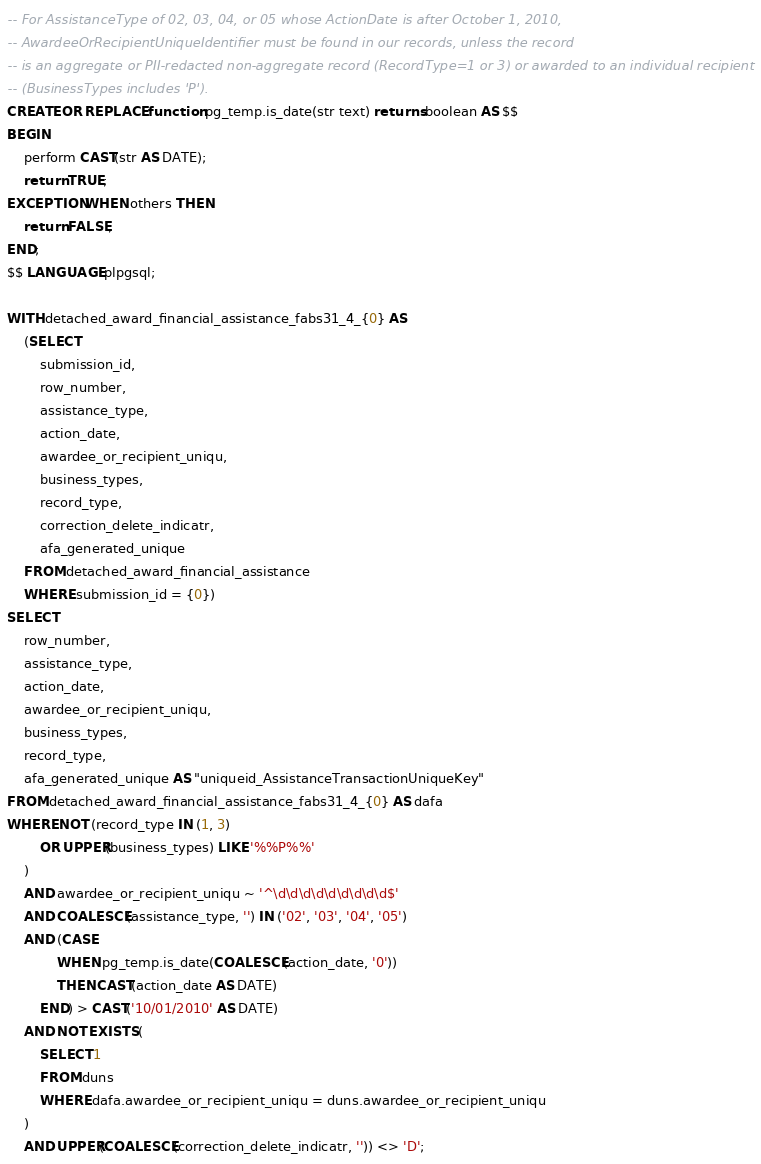Convert code to text. <code><loc_0><loc_0><loc_500><loc_500><_SQL_>-- For AssistanceType of 02, 03, 04, or 05 whose ActionDate is after October 1, 2010,
-- AwardeeOrRecipientUniqueIdentifier must be found in our records, unless the record
-- is an aggregate or PII-redacted non-aggregate record (RecordType=1 or 3) or awarded to an individual recipient
-- (BusinessTypes includes 'P').
CREATE OR REPLACE function pg_temp.is_date(str text) returns boolean AS $$
BEGIN
    perform CAST(str AS DATE);
    return TRUE;
EXCEPTION WHEN others THEN
    return FALSE;
END;
$$ LANGUAGE plpgsql;

WITH detached_award_financial_assistance_fabs31_4_{0} AS
    (SELECT
        submission_id,
        row_number,
        assistance_type,
        action_date,
        awardee_or_recipient_uniqu,
        business_types,
        record_type,
        correction_delete_indicatr,
        afa_generated_unique
    FROM detached_award_financial_assistance
    WHERE submission_id = {0})
SELECT
    row_number,
    assistance_type,
    action_date,
    awardee_or_recipient_uniqu,
    business_types,
    record_type,
    afa_generated_unique AS "uniqueid_AssistanceTransactionUniqueKey"
FROM detached_award_financial_assistance_fabs31_4_{0} AS dafa
WHERE NOT (record_type IN (1, 3)
        OR UPPER(business_types) LIKE '%%P%%'
    )
    AND awardee_or_recipient_uniqu ~ '^\d\d\d\d\d\d\d\d\d$'
    AND COALESCE(assistance_type, '') IN ('02', '03', '04', '05')
    AND (CASE
            WHEN pg_temp.is_date(COALESCE(action_date, '0'))
            THEN CAST(action_date AS DATE)
        END) > CAST('10/01/2010' AS DATE)
    AND NOT EXISTS (
        SELECT 1
        FROM duns
        WHERE dafa.awardee_or_recipient_uniqu = duns.awardee_or_recipient_uniqu
    )
    AND UPPER(COALESCE(correction_delete_indicatr, '')) <> 'D';
</code> 